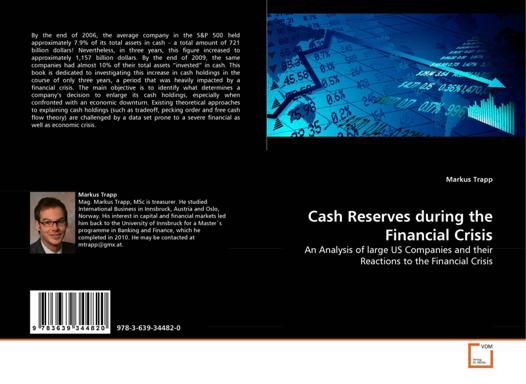Can you describe the kind of visual elements used on the cover of this book? The cover of the book 'Cash Reserves during the Financial Crisis' incorporates a blend of financial imagery and graphical representations. It features a background of blueprints and financial charts, overlaying images of currency and calculative figures. This design likely aims to convey the themes of analytics, finance, and systematic assessment. 